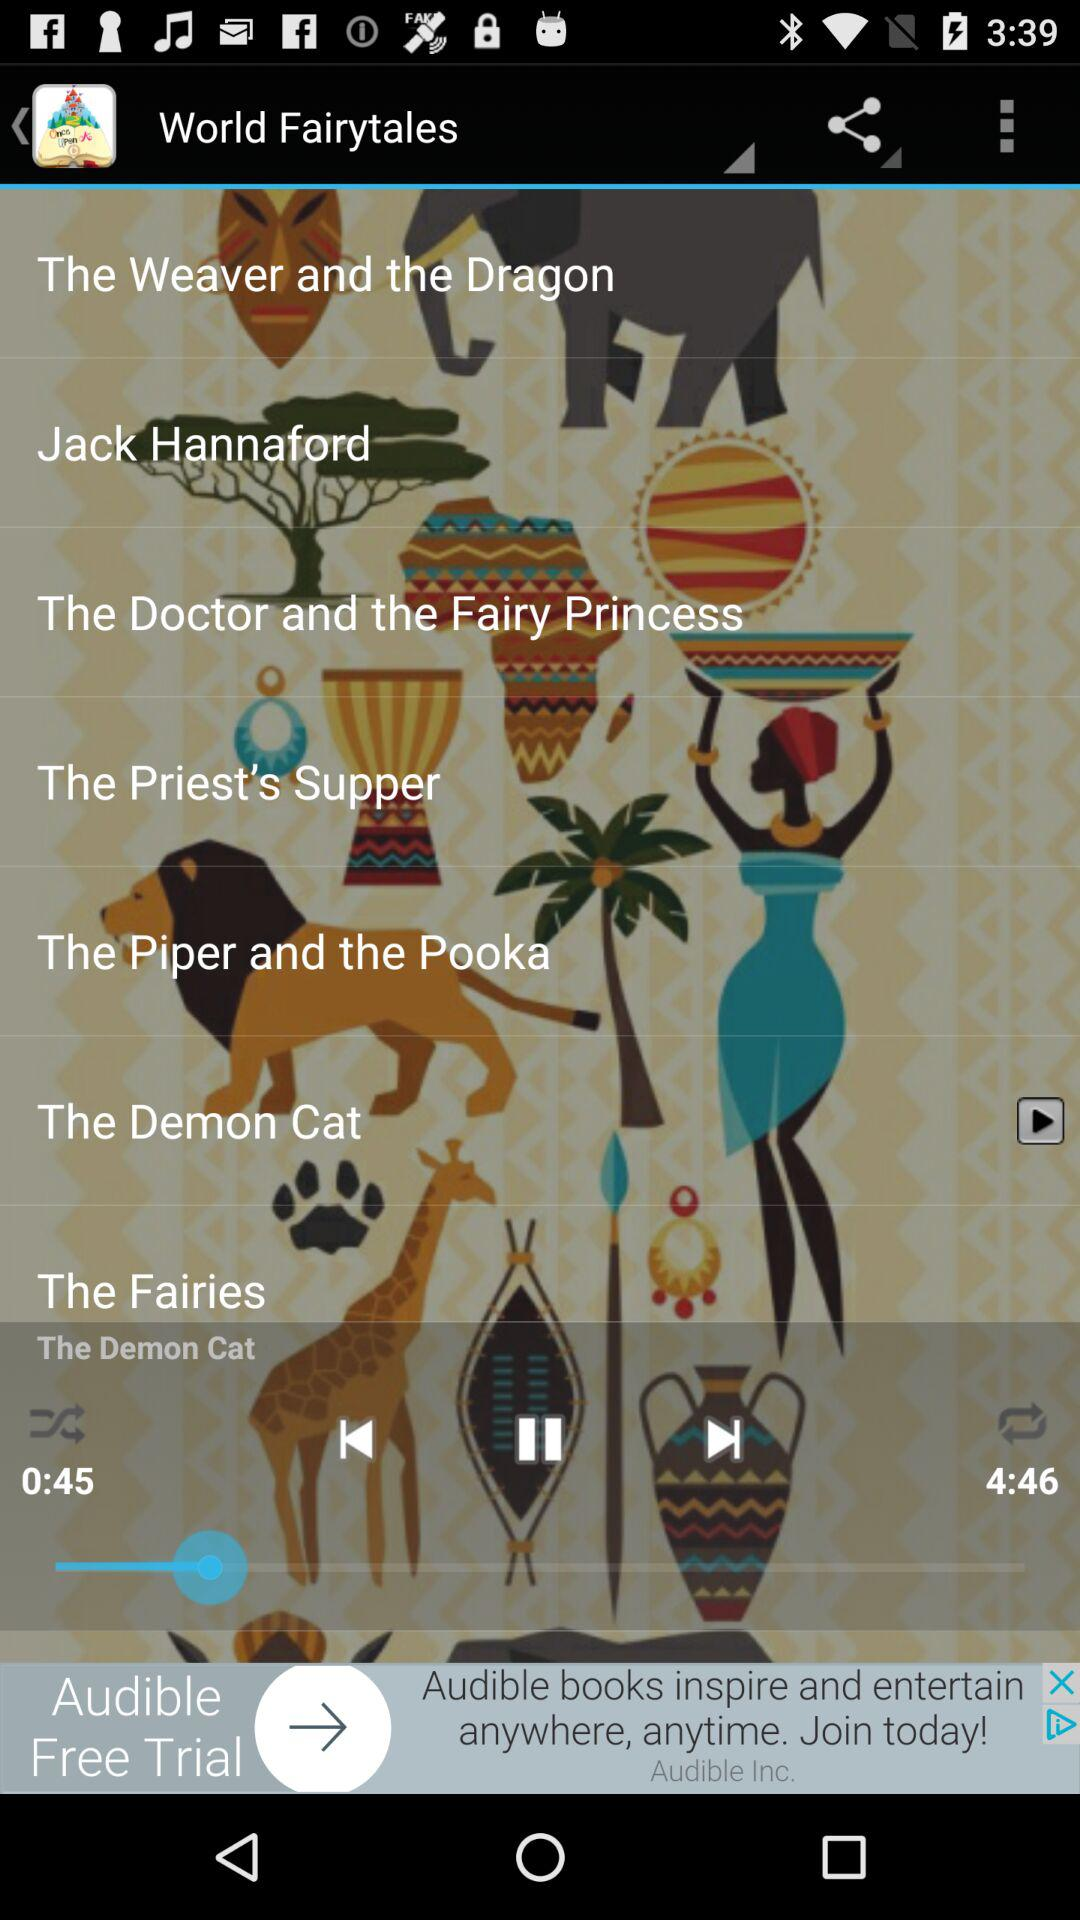How long has the audio been played for? The audio has been played for 45 seconds. 